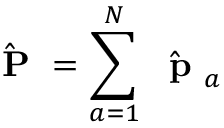Convert formula to latex. <formula><loc_0><loc_0><loc_500><loc_500>\hat { P } = \sum _ { a = 1 } ^ { N } \hat { p } _ { a }</formula> 